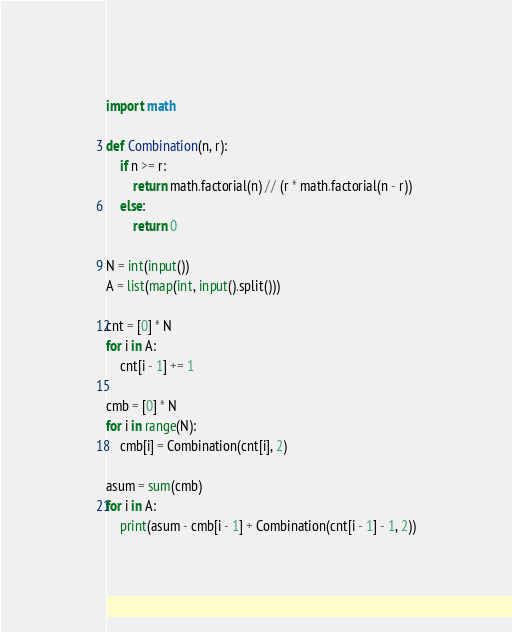<code> <loc_0><loc_0><loc_500><loc_500><_Python_>import math

def Combination(n, r):
	if n >= r:
		return math.factorial(n) // (r * math.factorial(n - r))
	else:
		return 0

N = int(input())
A = list(map(int, input().split()))

cnt = [0] * N
for i in A:
	cnt[i - 1] += 1

cmb = [0] * N
for i in range(N):
	cmb[i] = Combination(cnt[i], 2)

asum = sum(cmb)
for i in A:
	print(asum - cmb[i - 1] + Combination(cnt[i - 1] - 1, 2))</code> 